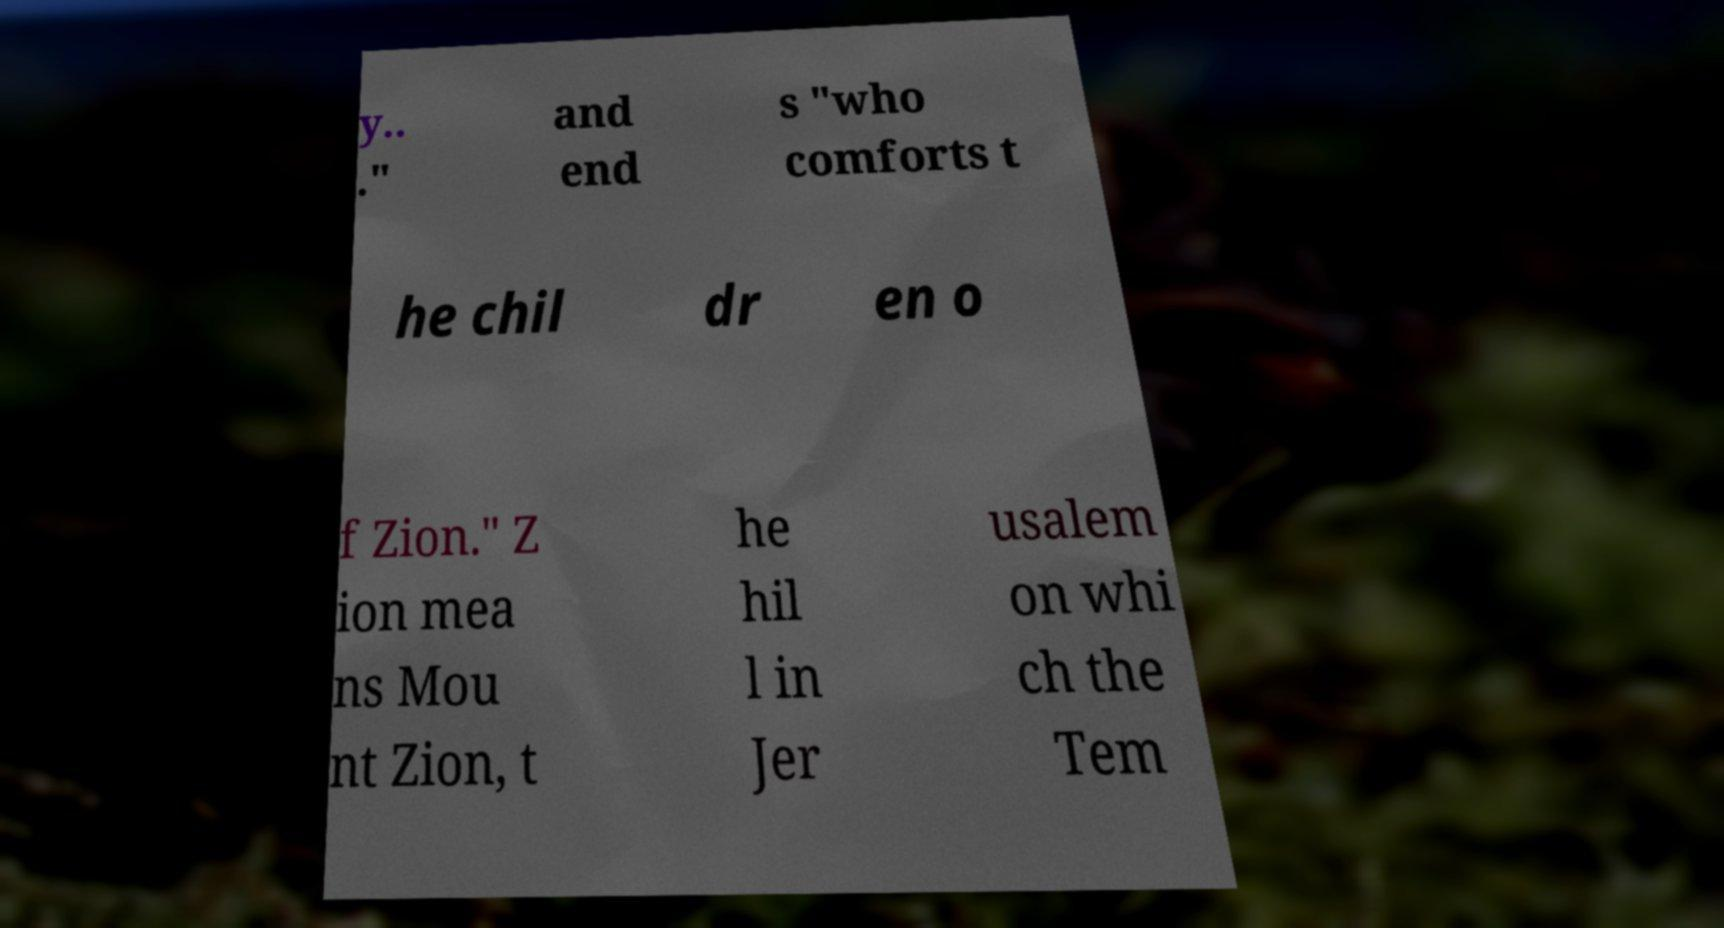Could you assist in decoding the text presented in this image and type it out clearly? y.. ." and end s "who comforts t he chil dr en o f Zion." Z ion mea ns Mou nt Zion, t he hil l in Jer usalem on whi ch the Tem 